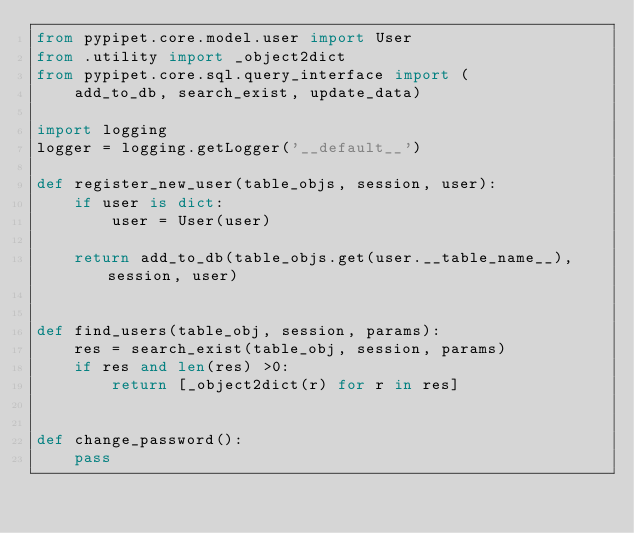<code> <loc_0><loc_0><loc_500><loc_500><_Python_>from pypipet.core.model.user import User
from .utility import _object2dict
from pypipet.core.sql.query_interface import (
    add_to_db, search_exist, update_data)

import logging
logger = logging.getLogger('__default__')

def register_new_user(table_objs, session, user):
    if user is dict:
        user = User(user)
    
    return add_to_db(table_objs.get(user.__table_name__), session, user) 


def find_users(table_obj, session, params):
    res = search_exist(table_obj, session, params)
    if res and len(res) >0:
        return [_object2dict(r) for r in res]


def change_password():
    pass</code> 